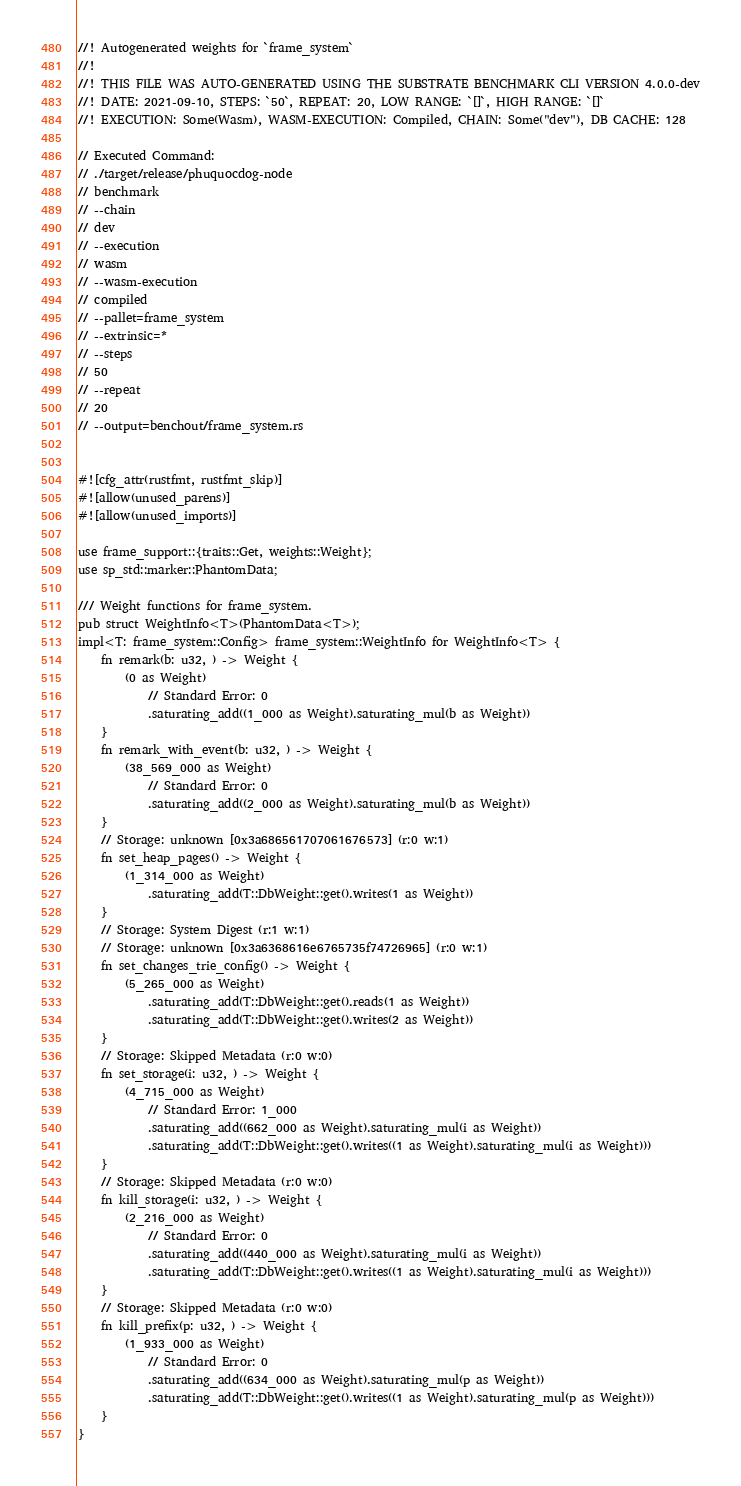<code> <loc_0><loc_0><loc_500><loc_500><_Rust_>
//! Autogenerated weights for `frame_system`
//!
//! THIS FILE WAS AUTO-GENERATED USING THE SUBSTRATE BENCHMARK CLI VERSION 4.0.0-dev
//! DATE: 2021-09-10, STEPS: `50`, REPEAT: 20, LOW RANGE: `[]`, HIGH RANGE: `[]`
//! EXECUTION: Some(Wasm), WASM-EXECUTION: Compiled, CHAIN: Some("dev"), DB CACHE: 128

// Executed Command:
// ./target/release/phuquocdog-node
// benchmark
// --chain
// dev
// --execution
// wasm
// --wasm-execution
// compiled
// --pallet=frame_system
// --extrinsic=*
// --steps
// 50
// --repeat
// 20
// --output=benchout/frame_system.rs


#![cfg_attr(rustfmt, rustfmt_skip)]
#![allow(unused_parens)]
#![allow(unused_imports)]

use frame_support::{traits::Get, weights::Weight};
use sp_std::marker::PhantomData;

/// Weight functions for frame_system.
pub struct WeightInfo<T>(PhantomData<T>);
impl<T: frame_system::Config> frame_system::WeightInfo for WeightInfo<T> {
	fn remark(b: u32, ) -> Weight {
		(0 as Weight)
			// Standard Error: 0
			.saturating_add((1_000 as Weight).saturating_mul(b as Weight))
	}
	fn remark_with_event(b: u32, ) -> Weight {
		(38_569_000 as Weight)
			// Standard Error: 0
			.saturating_add((2_000 as Weight).saturating_mul(b as Weight))
	}
	// Storage: unknown [0x3a686561707061676573] (r:0 w:1)
	fn set_heap_pages() -> Weight {
		(1_314_000 as Weight)
			.saturating_add(T::DbWeight::get().writes(1 as Weight))
	}
	// Storage: System Digest (r:1 w:1)
	// Storage: unknown [0x3a6368616e6765735f74726965] (r:0 w:1)
	fn set_changes_trie_config() -> Weight {
		(5_265_000 as Weight)
			.saturating_add(T::DbWeight::get().reads(1 as Weight))
			.saturating_add(T::DbWeight::get().writes(2 as Weight))
	}
	// Storage: Skipped Metadata (r:0 w:0)
	fn set_storage(i: u32, ) -> Weight {
		(4_715_000 as Weight)
			// Standard Error: 1_000
			.saturating_add((662_000 as Weight).saturating_mul(i as Weight))
			.saturating_add(T::DbWeight::get().writes((1 as Weight).saturating_mul(i as Weight)))
	}
	// Storage: Skipped Metadata (r:0 w:0)
	fn kill_storage(i: u32, ) -> Weight {
		(2_216_000 as Weight)
			// Standard Error: 0
			.saturating_add((440_000 as Weight).saturating_mul(i as Weight))
			.saturating_add(T::DbWeight::get().writes((1 as Weight).saturating_mul(i as Weight)))
	}
	// Storage: Skipped Metadata (r:0 w:0)
	fn kill_prefix(p: u32, ) -> Weight {
		(1_933_000 as Weight)
			// Standard Error: 0
			.saturating_add((634_000 as Weight).saturating_mul(p as Weight))
			.saturating_add(T::DbWeight::get().writes((1 as Weight).saturating_mul(p as Weight)))
	}
}
</code> 